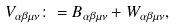Convert formula to latex. <formula><loc_0><loc_0><loc_500><loc_500>V _ { \alpha \beta \mu \nu } \colon = B _ { \alpha \beta \mu \nu } + W _ { \alpha \beta \mu \nu } ,</formula> 